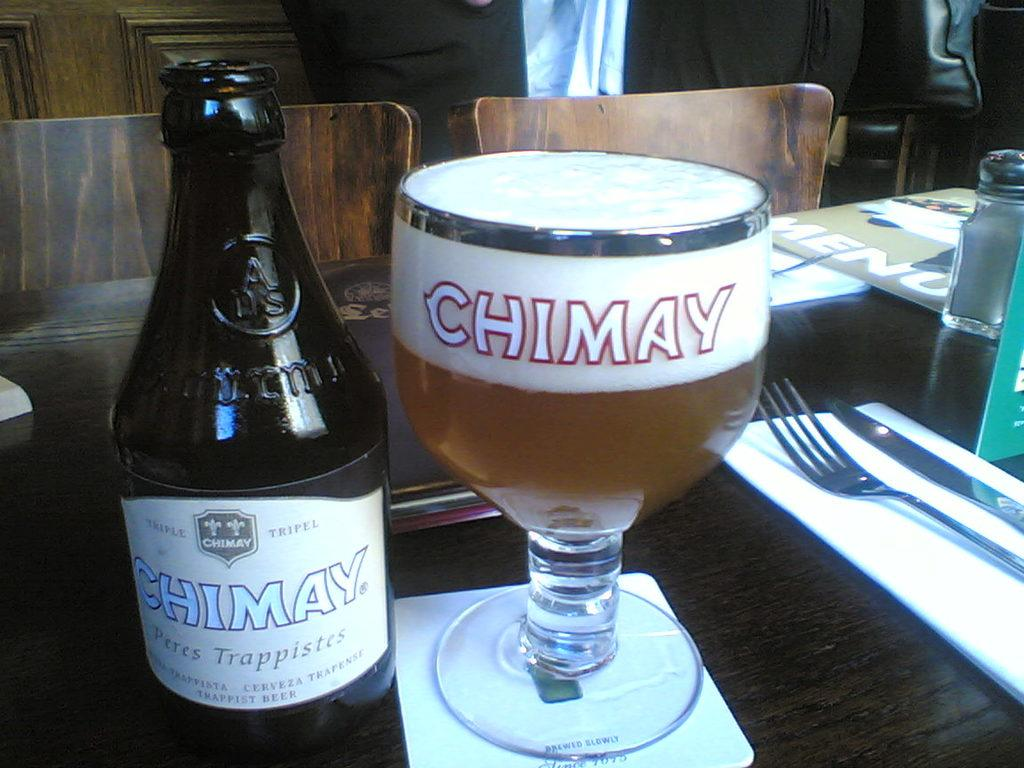What objects are on the table in the image? There is a bottle, a glass, a fork, and a knife on the table in the image. Is there any reading material present in the image? Yes, there is a book on the table or nearby. What type of seating is visible in the background of the image? There are chairs visible in the background of the image. What type of note can be seen on the airport runway in the image? There is no airport or runway present in the image, and therefore no note can be seen. 